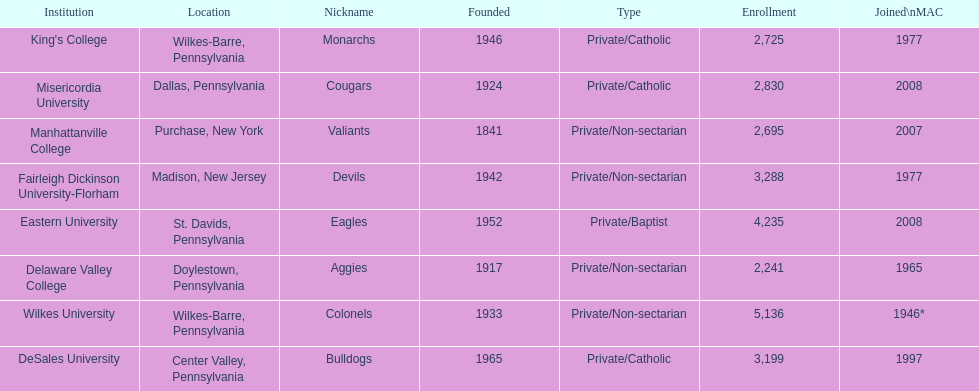What is the enrollment number of misericordia university? 2,830. 